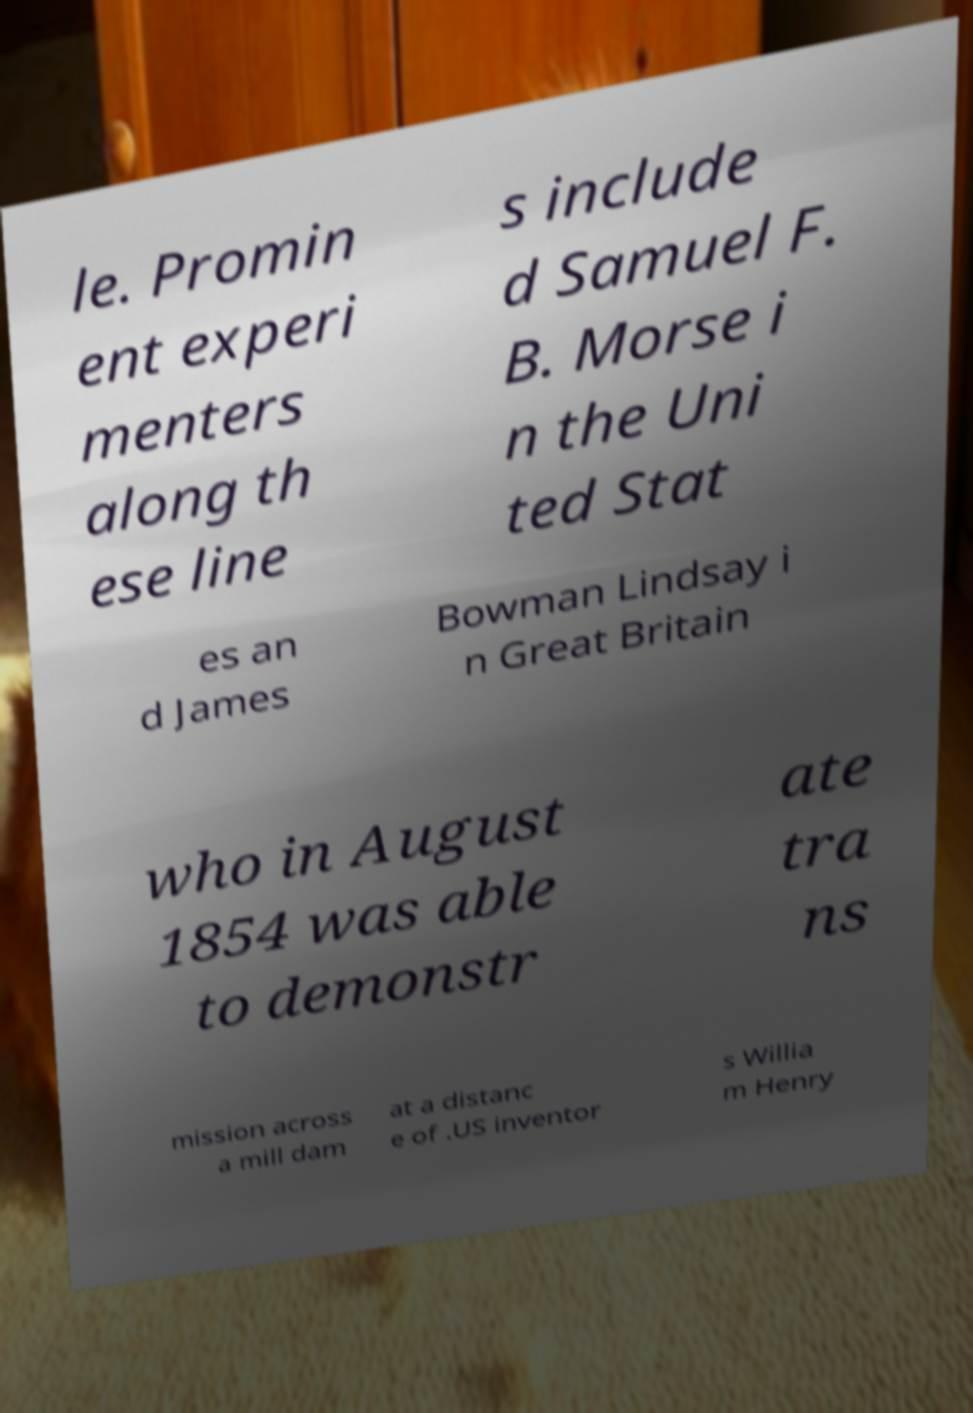Can you read and provide the text displayed in the image?This photo seems to have some interesting text. Can you extract and type it out for me? le. Promin ent experi menters along th ese line s include d Samuel F. B. Morse i n the Uni ted Stat es an d James Bowman Lindsay i n Great Britain who in August 1854 was able to demonstr ate tra ns mission across a mill dam at a distanc e of .US inventor s Willia m Henry 